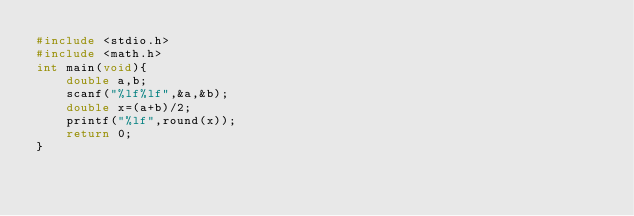Convert code to text. <code><loc_0><loc_0><loc_500><loc_500><_C_>#include <stdio.h>
#include <math.h>
int main(void){
    double a,b;
    scanf("%lf%lf",&a,&b);
    double x=(a+b)/2;
    printf("%lf",round(x));
    return 0;
}</code> 